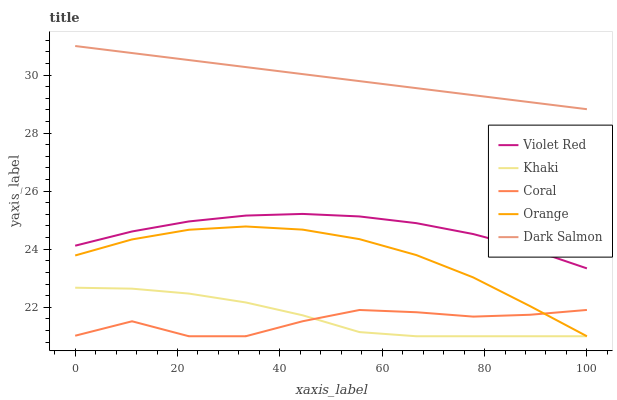Does Coral have the minimum area under the curve?
Answer yes or no. Yes. Does Dark Salmon have the maximum area under the curve?
Answer yes or no. Yes. Does Violet Red have the minimum area under the curve?
Answer yes or no. No. Does Violet Red have the maximum area under the curve?
Answer yes or no. No. Is Dark Salmon the smoothest?
Answer yes or no. Yes. Is Coral the roughest?
Answer yes or no. Yes. Is Violet Red the smoothest?
Answer yes or no. No. Is Violet Red the roughest?
Answer yes or no. No. Does Orange have the lowest value?
Answer yes or no. Yes. Does Violet Red have the lowest value?
Answer yes or no. No. Does Dark Salmon have the highest value?
Answer yes or no. Yes. Does Violet Red have the highest value?
Answer yes or no. No. Is Coral less than Violet Red?
Answer yes or no. Yes. Is Dark Salmon greater than Violet Red?
Answer yes or no. Yes. Does Coral intersect Khaki?
Answer yes or no. Yes. Is Coral less than Khaki?
Answer yes or no. No. Is Coral greater than Khaki?
Answer yes or no. No. Does Coral intersect Violet Red?
Answer yes or no. No. 